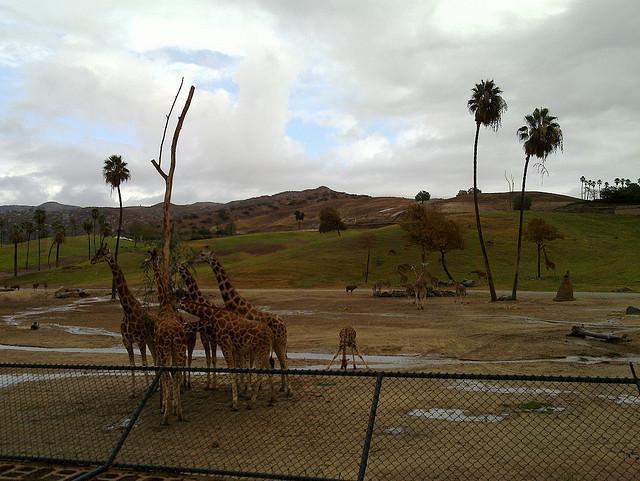What type of enclosure is shown?
Indicate the correct response by choosing from the four available options to answer the question.
Options: Fence, barn, cage, gate. Fence. 